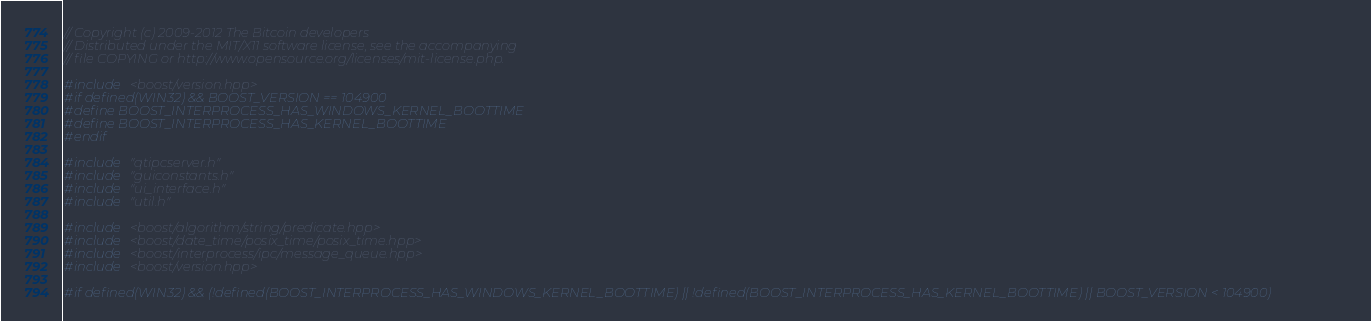Convert code to text. <code><loc_0><loc_0><loc_500><loc_500><_C++_>// Copyright (c) 2009-2012 The Bitcoin developers
// Distributed under the MIT/X11 software license, see the accompanying
// file COPYING or http://www.opensource.org/licenses/mit-license.php.

#include <boost/version.hpp>
#if defined(WIN32) && BOOST_VERSION == 104900
#define BOOST_INTERPROCESS_HAS_WINDOWS_KERNEL_BOOTTIME
#define BOOST_INTERPROCESS_HAS_KERNEL_BOOTTIME
#endif

#include "qtipcserver.h"
#include "guiconstants.h"
#include "ui_interface.h"
#include "util.h"

#include <boost/algorithm/string/predicate.hpp>
#include <boost/date_time/posix_time/posix_time.hpp>
#include <boost/interprocess/ipc/message_queue.hpp>
#include <boost/version.hpp>

#if defined(WIN32) && (!defined(BOOST_INTERPROCESS_HAS_WINDOWS_KERNEL_BOOTTIME) || !defined(BOOST_INTERPROCESS_HAS_KERNEL_BOOTTIME) || BOOST_VERSION < 104900)</code> 